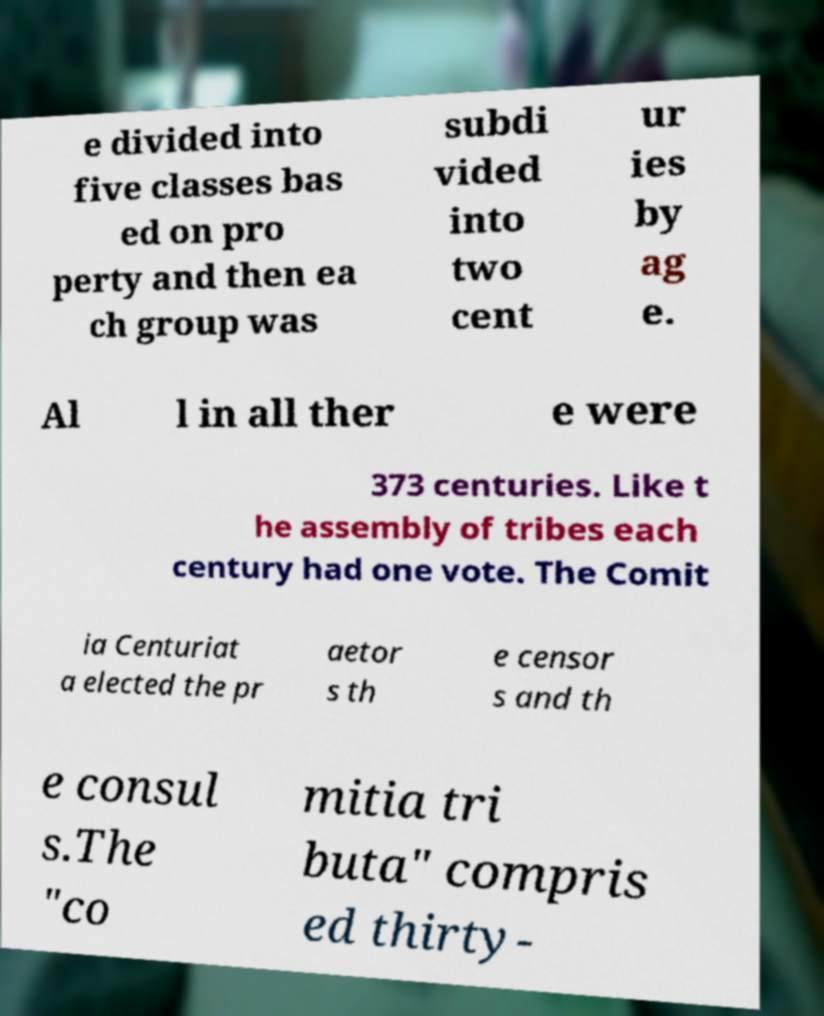What messages or text are displayed in this image? I need them in a readable, typed format. e divided into five classes bas ed on pro perty and then ea ch group was subdi vided into two cent ur ies by ag e. Al l in all ther e were 373 centuries. Like t he assembly of tribes each century had one vote. The Comit ia Centuriat a elected the pr aetor s th e censor s and th e consul s.The "co mitia tri buta" compris ed thirty- 